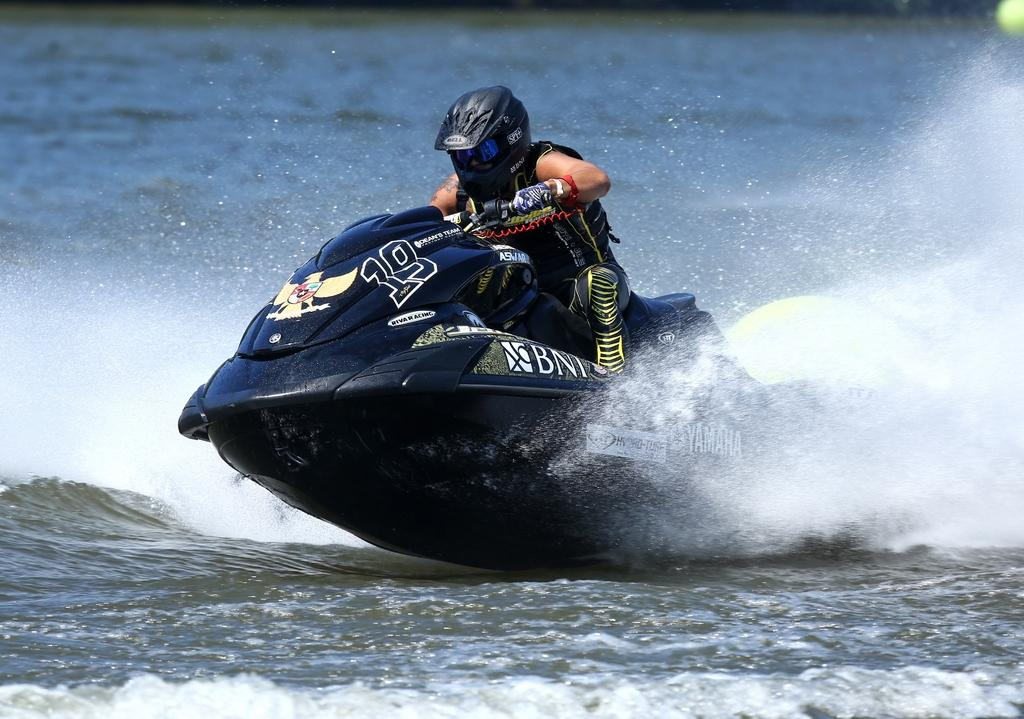What is the man in the image doing? The man is riding a jet ski in the image. Where is the jet ski located? The jet ski is on the water in the image. How does the man compare the weight of the hammer to the jet ski in the image? There is no hammer present in the image, so it is not possible to make a comparison between the weight of a hammer and the jet ski. 